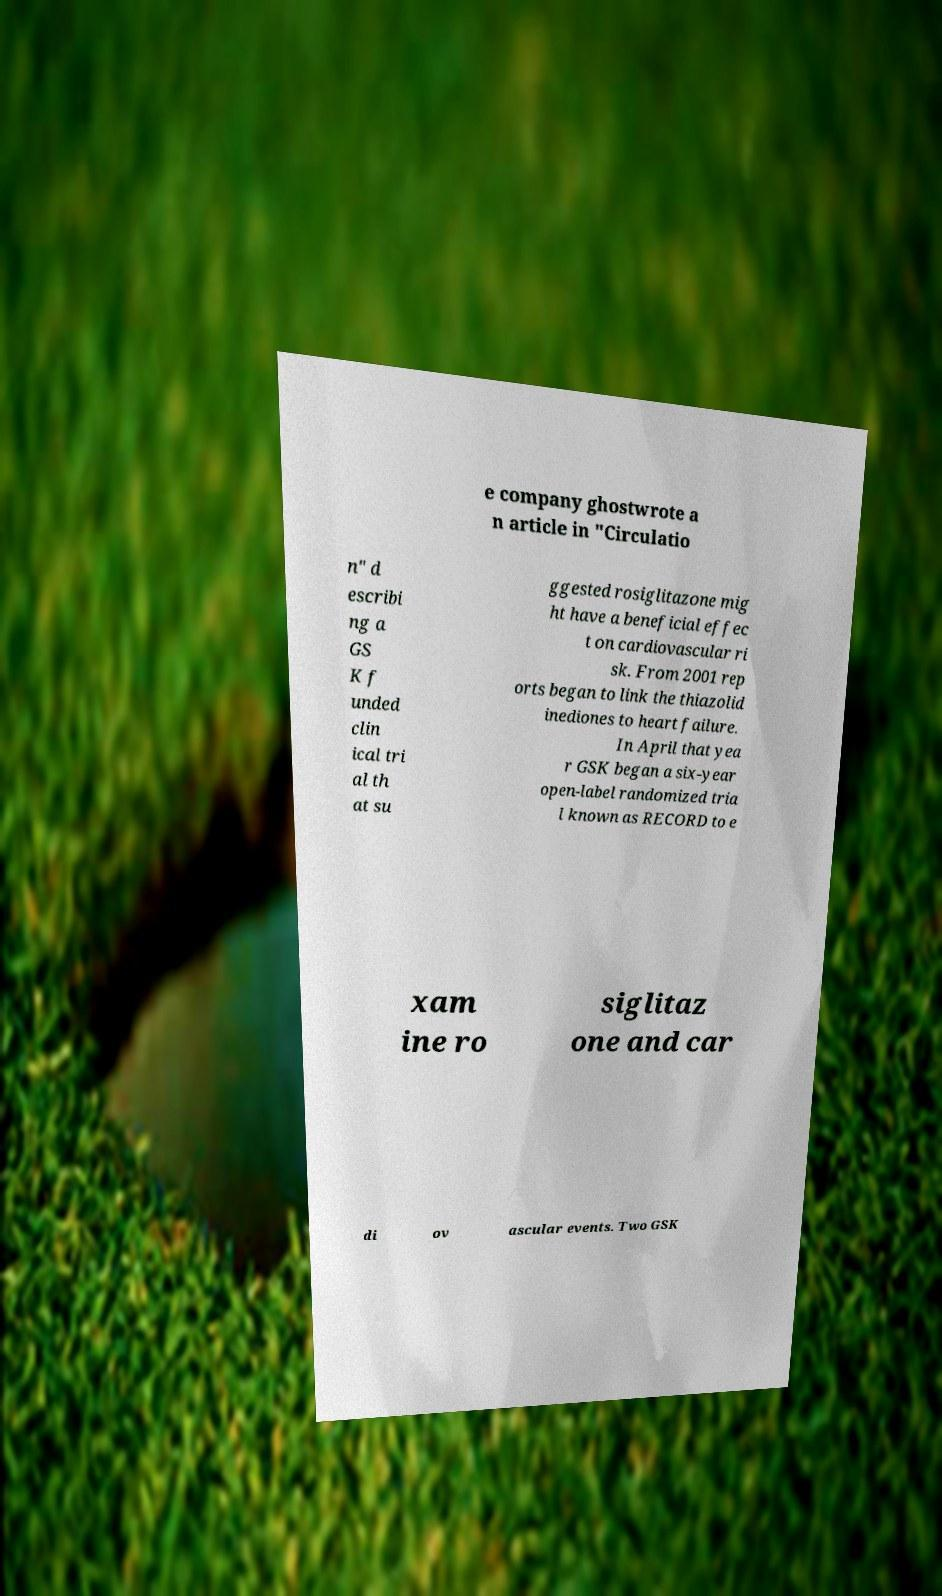Can you read and provide the text displayed in the image?This photo seems to have some interesting text. Can you extract and type it out for me? e company ghostwrote a n article in "Circulatio n" d escribi ng a GS K f unded clin ical tri al th at su ggested rosiglitazone mig ht have a beneficial effec t on cardiovascular ri sk. From 2001 rep orts began to link the thiazolid inediones to heart failure. In April that yea r GSK began a six-year open-label randomized tria l known as RECORD to e xam ine ro siglitaz one and car di ov ascular events. Two GSK 